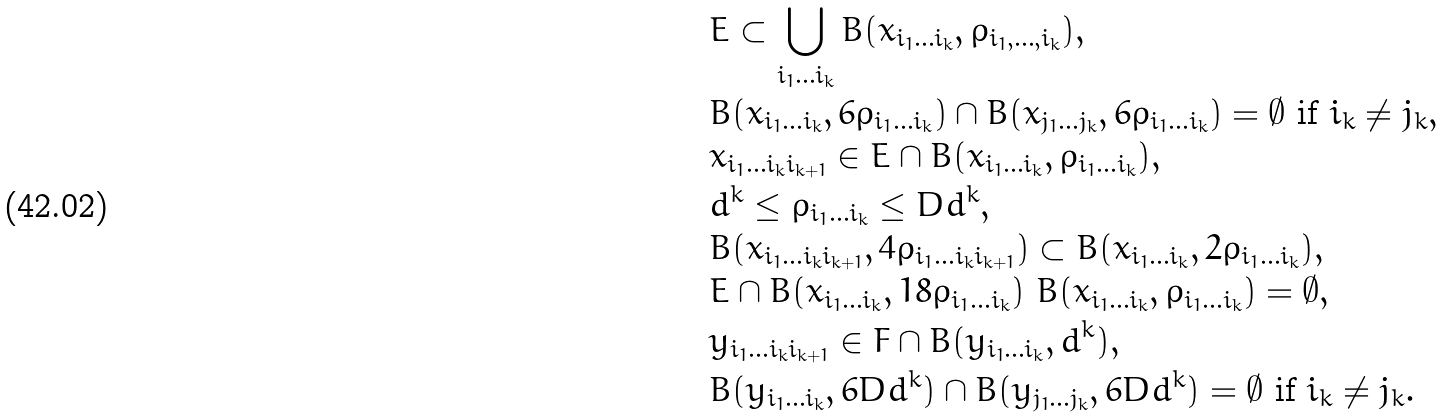Convert formula to latex. <formula><loc_0><loc_0><loc_500><loc_500>& E \subset \bigcup _ { i _ { 1 } \dots i _ { k } } B ( x _ { i _ { 1 } \dots i _ { k } } , \rho _ { i _ { 1 } , \dots , i _ { k } } ) , \\ & B ( x _ { i _ { 1 } \dots i _ { k } } , 6 \rho _ { i _ { 1 } \dots i _ { k } } ) \cap B ( x _ { j _ { 1 } \dots j _ { k } } , 6 \rho _ { i _ { 1 } \dots i _ { k } } ) = \emptyset \ \text {if} \ i _ { k } \not = j _ { k } , \\ & x _ { i _ { 1 } \dots i _ { k } i _ { k + 1 } } \in E \cap B ( x _ { i _ { 1 } \dots i _ { k } } , \rho _ { i _ { 1 } \dots i _ { k } } ) , \\ & d ^ { k } \leq \rho _ { i _ { 1 } \dots i _ { k } } \leq D d ^ { k } , \\ & B ( x _ { i _ { 1 } \dots i _ { k } i _ { k + 1 } } , 4 \rho _ { i _ { 1 } \dots i _ { k } i _ { k + 1 } } ) \subset B ( x _ { i _ { 1 } \dots i _ { k } } , 2 \rho _ { i _ { 1 } \dots i _ { k } } ) , \\ & E \cap B ( x _ { i _ { 1 } \dots i _ { k } } , 1 8 \rho _ { i _ { 1 } \dots i _ { k } } ) \ B ( x _ { i _ { 1 } \dots i _ { k } } , \rho _ { i _ { 1 } \dots i _ { k } } ) = \emptyset , \\ & y _ { i _ { 1 } \dots i _ { k } i _ { k + 1 } } \in F \cap B ( y _ { i _ { 1 } \dots i _ { k } } , d ^ { k } ) , \\ & B ( y _ { i _ { 1 } \dots i _ { k } } , 6 D d ^ { k } ) \cap B ( y _ { j _ { 1 } \dots j _ { k } } , 6 D d ^ { k } ) = \emptyset \ \text {if} \ i _ { k } \not = j _ { k } .</formula> 